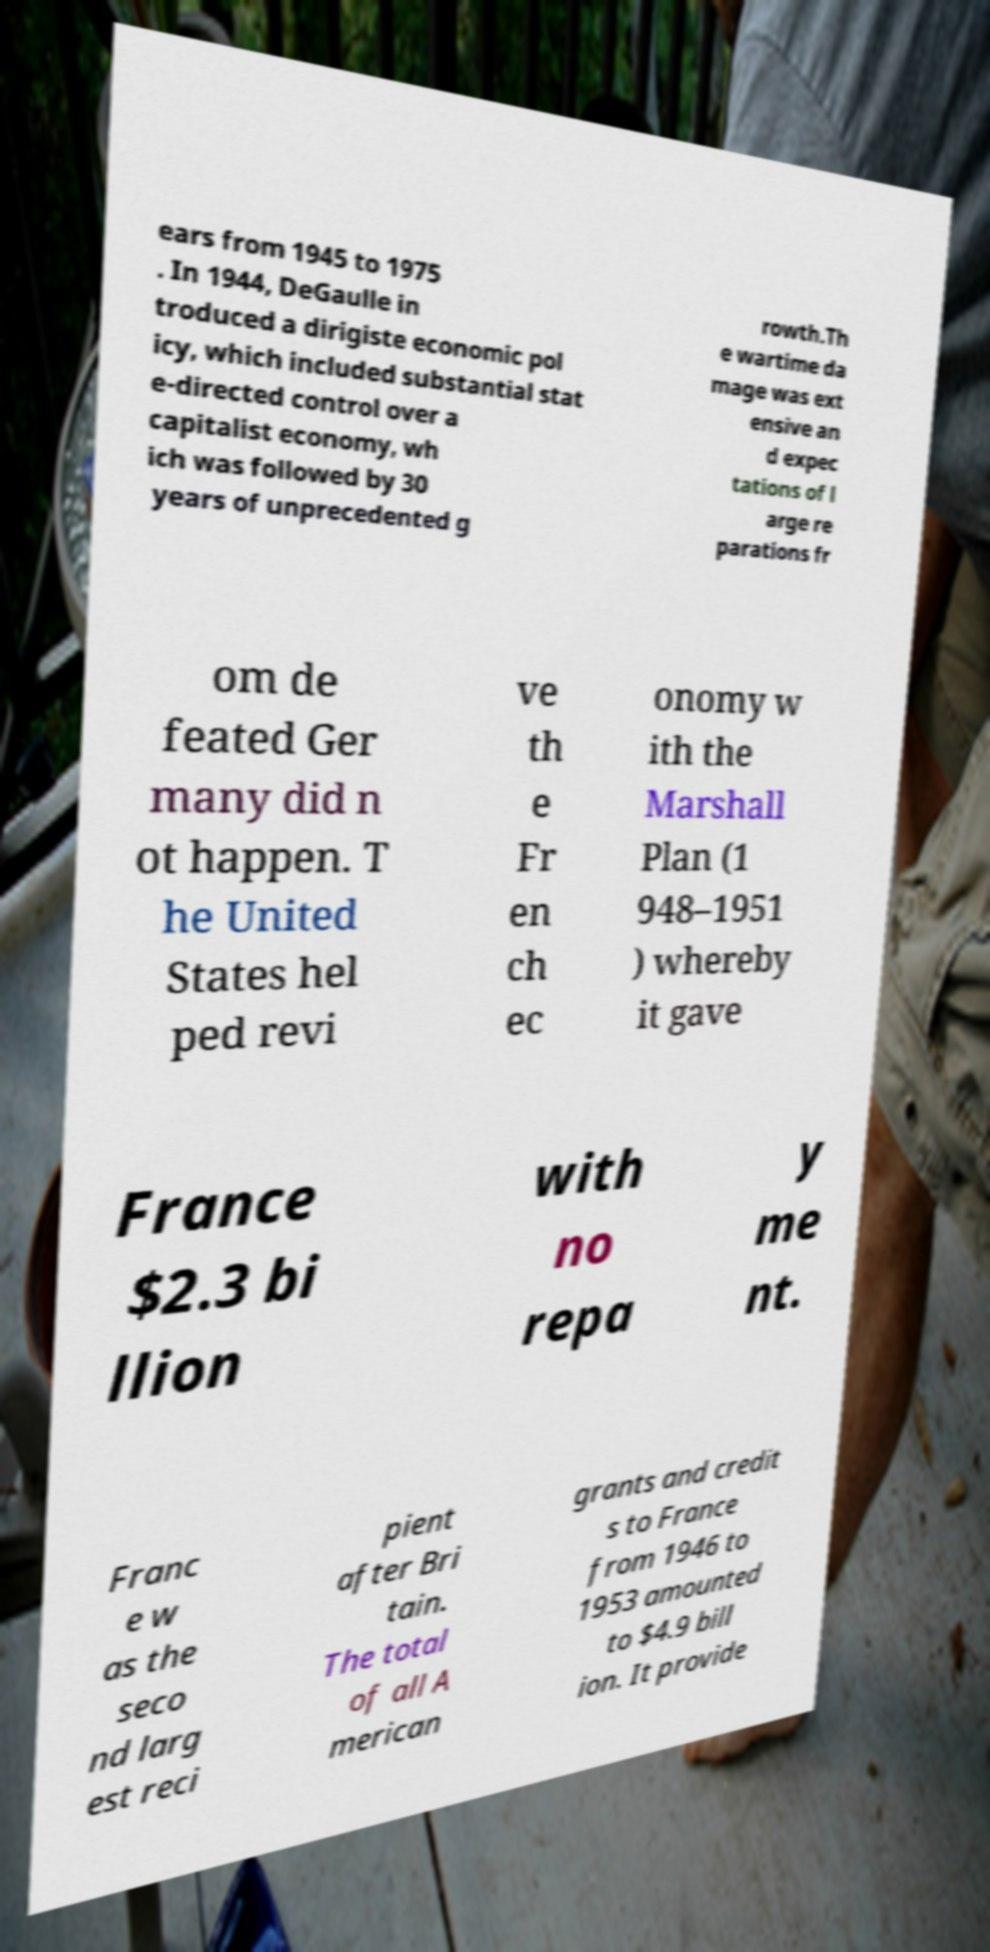What messages or text are displayed in this image? I need them in a readable, typed format. ears from 1945 to 1975 . In 1944, DeGaulle in troduced a dirigiste economic pol icy, which included substantial stat e-directed control over a capitalist economy, wh ich was followed by 30 years of unprecedented g rowth.Th e wartime da mage was ext ensive an d expec tations of l arge re parations fr om de feated Ger many did n ot happen. T he United States hel ped revi ve th e Fr en ch ec onomy w ith the Marshall Plan (1 948–1951 ) whereby it gave France $2.3 bi llion with no repa y me nt. Franc e w as the seco nd larg est reci pient after Bri tain. The total of all A merican grants and credit s to France from 1946 to 1953 amounted to $4.9 bill ion. It provide 